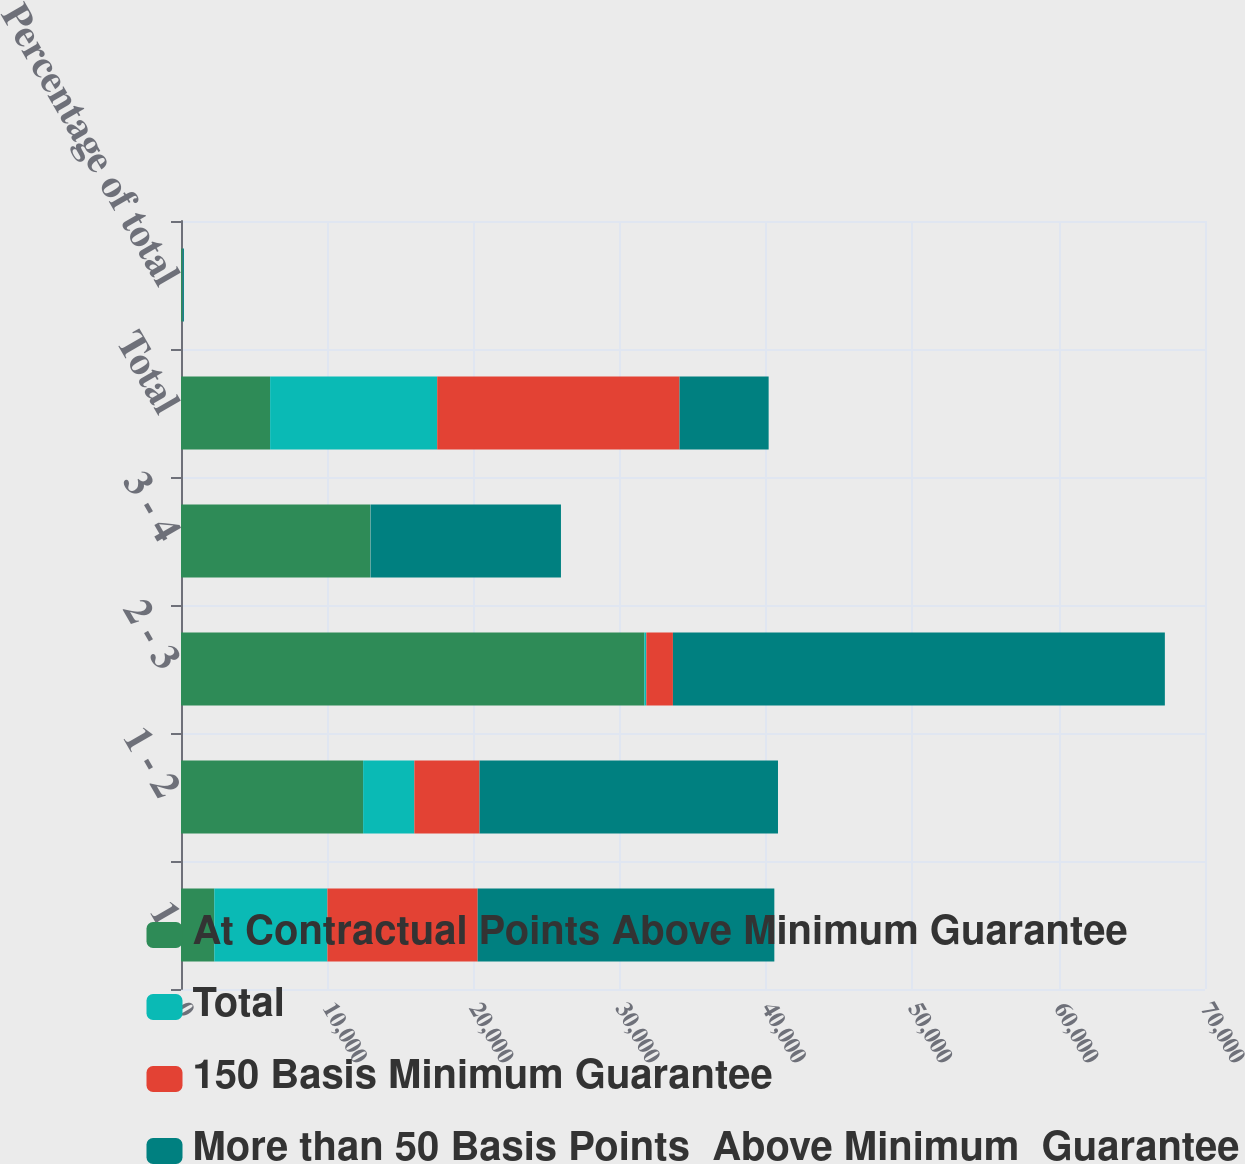Convert chart. <chart><loc_0><loc_0><loc_500><loc_500><stacked_bar_chart><ecel><fcel>1<fcel>1 - 2<fcel>2 - 3<fcel>3 - 4<fcel>Total<fcel>Percentage of total<nl><fcel>At Contractual Points Above Minimum Guarantee<fcel>2277<fcel>12450<fcel>31674<fcel>12922<fcel>6092.5<fcel>71<nl><fcel>Total<fcel>7732<fcel>3502<fcel>136<fcel>51<fcel>11421<fcel>12<nl><fcel>150 Basis Minimum Guarantee<fcel>10271<fcel>4453<fcel>1818<fcel>14<fcel>16565<fcel>17<nl><fcel>More than 50 Basis Points  Above Minimum  Guarantee<fcel>20280<fcel>20405<fcel>33628<fcel>12987<fcel>6092.5<fcel>100<nl></chart> 